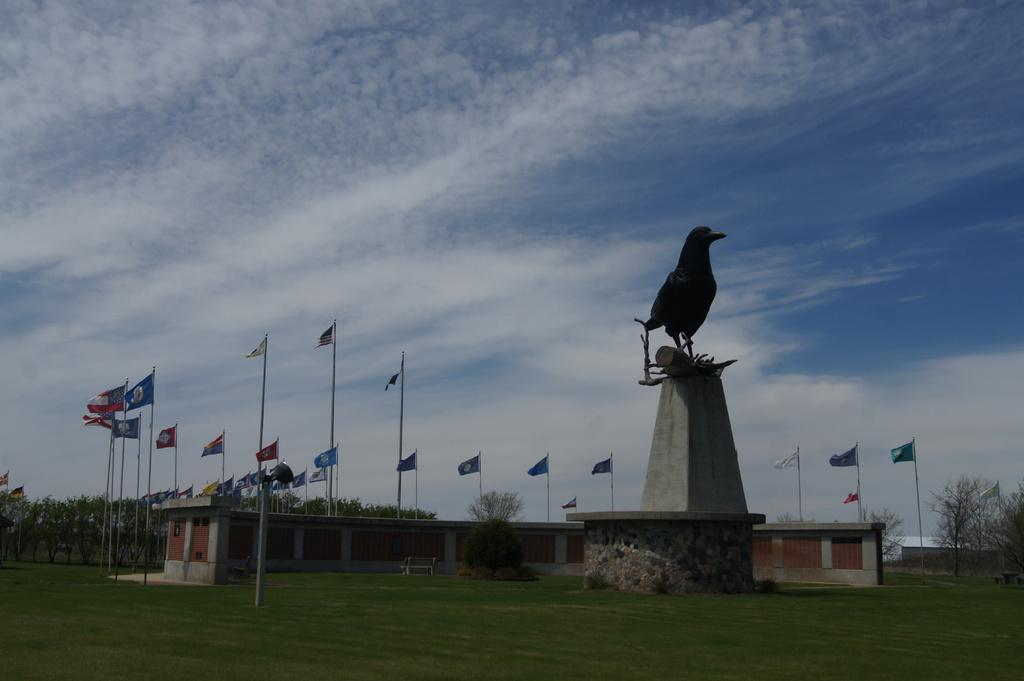What type of vegetation can be seen in the image? There is grass in the image. What type of structures are visible in the image? There are buildings in the image. What other objects can be seen in the image? There are flags and a bird statue in the image. What type of natural elements are present in the image? There are trees in the image. What is visible in the background of the image? The sky is visible in the image, and clouds are present in the sky. Can you tell me how many boats are in the image? There are no boats present in the image. Who is the creator of the bird statue in the image? The creator of the bird statue is not mentioned in the image or the provided facts. 